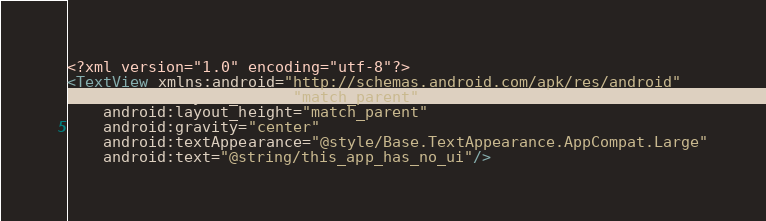<code> <loc_0><loc_0><loc_500><loc_500><_XML_><?xml version="1.0" encoding="utf-8"?>
<TextView xmlns:android="http://schemas.android.com/apk/res/android"
    android:layout_width="match_parent"
    android:layout_height="match_parent"
    android:gravity="center"
    android:textAppearance="@style/Base.TextAppearance.AppCompat.Large"
    android:text="@string/this_app_has_no_ui"/>
</code> 